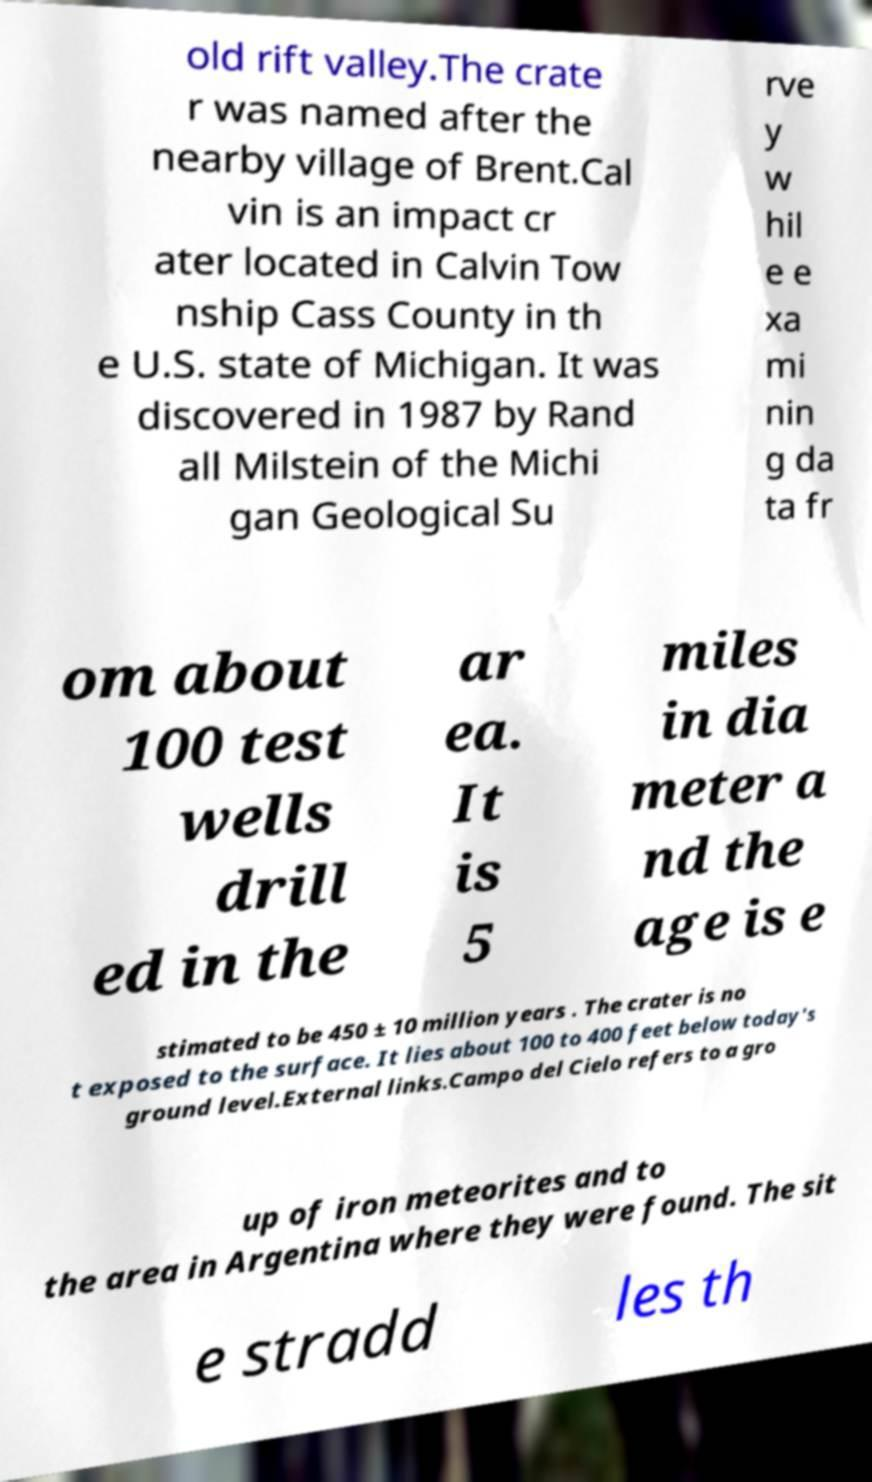Can you read and provide the text displayed in the image?This photo seems to have some interesting text. Can you extract and type it out for me? old rift valley.The crate r was named after the nearby village of Brent.Cal vin is an impact cr ater located in Calvin Tow nship Cass County in th e U.S. state of Michigan. It was discovered in 1987 by Rand all Milstein of the Michi gan Geological Su rve y w hil e e xa mi nin g da ta fr om about 100 test wells drill ed in the ar ea. It is 5 miles in dia meter a nd the age is e stimated to be 450 ± 10 million years . The crater is no t exposed to the surface. It lies about 100 to 400 feet below today's ground level.External links.Campo del Cielo refers to a gro up of iron meteorites and to the area in Argentina where they were found. The sit e stradd les th 